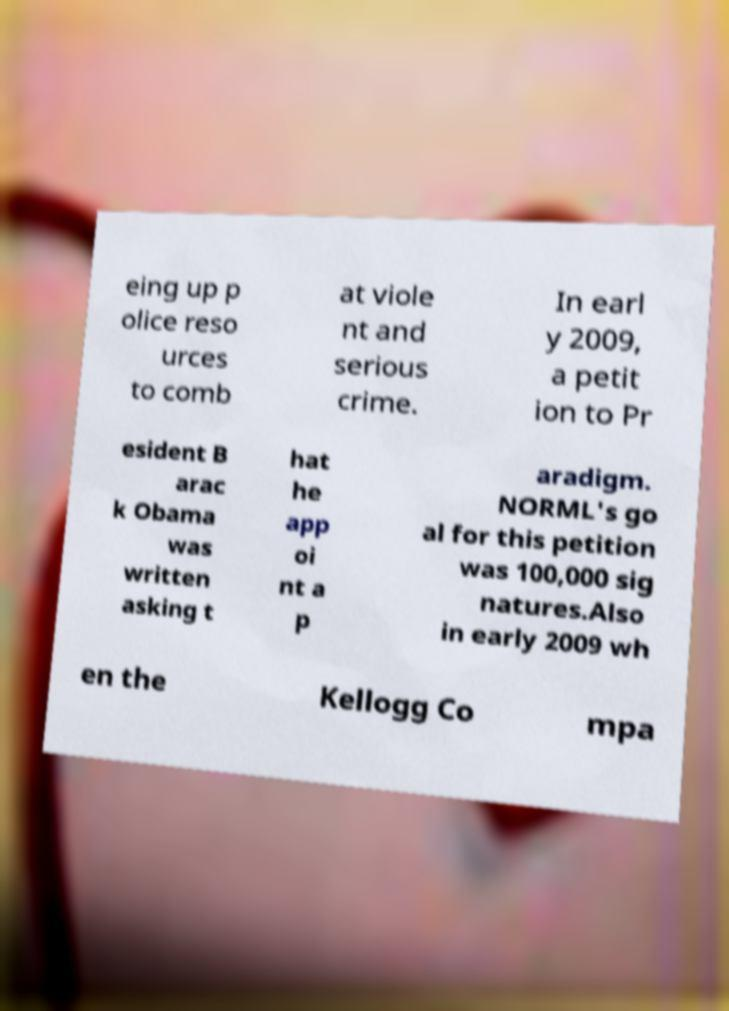Can you read and provide the text displayed in the image?This photo seems to have some interesting text. Can you extract and type it out for me? eing up p olice reso urces to comb at viole nt and serious crime. In earl y 2009, a petit ion to Pr esident B arac k Obama was written asking t hat he app oi nt a p aradigm. NORML's go al for this petition was 100,000 sig natures.Also in early 2009 wh en the Kellogg Co mpa 